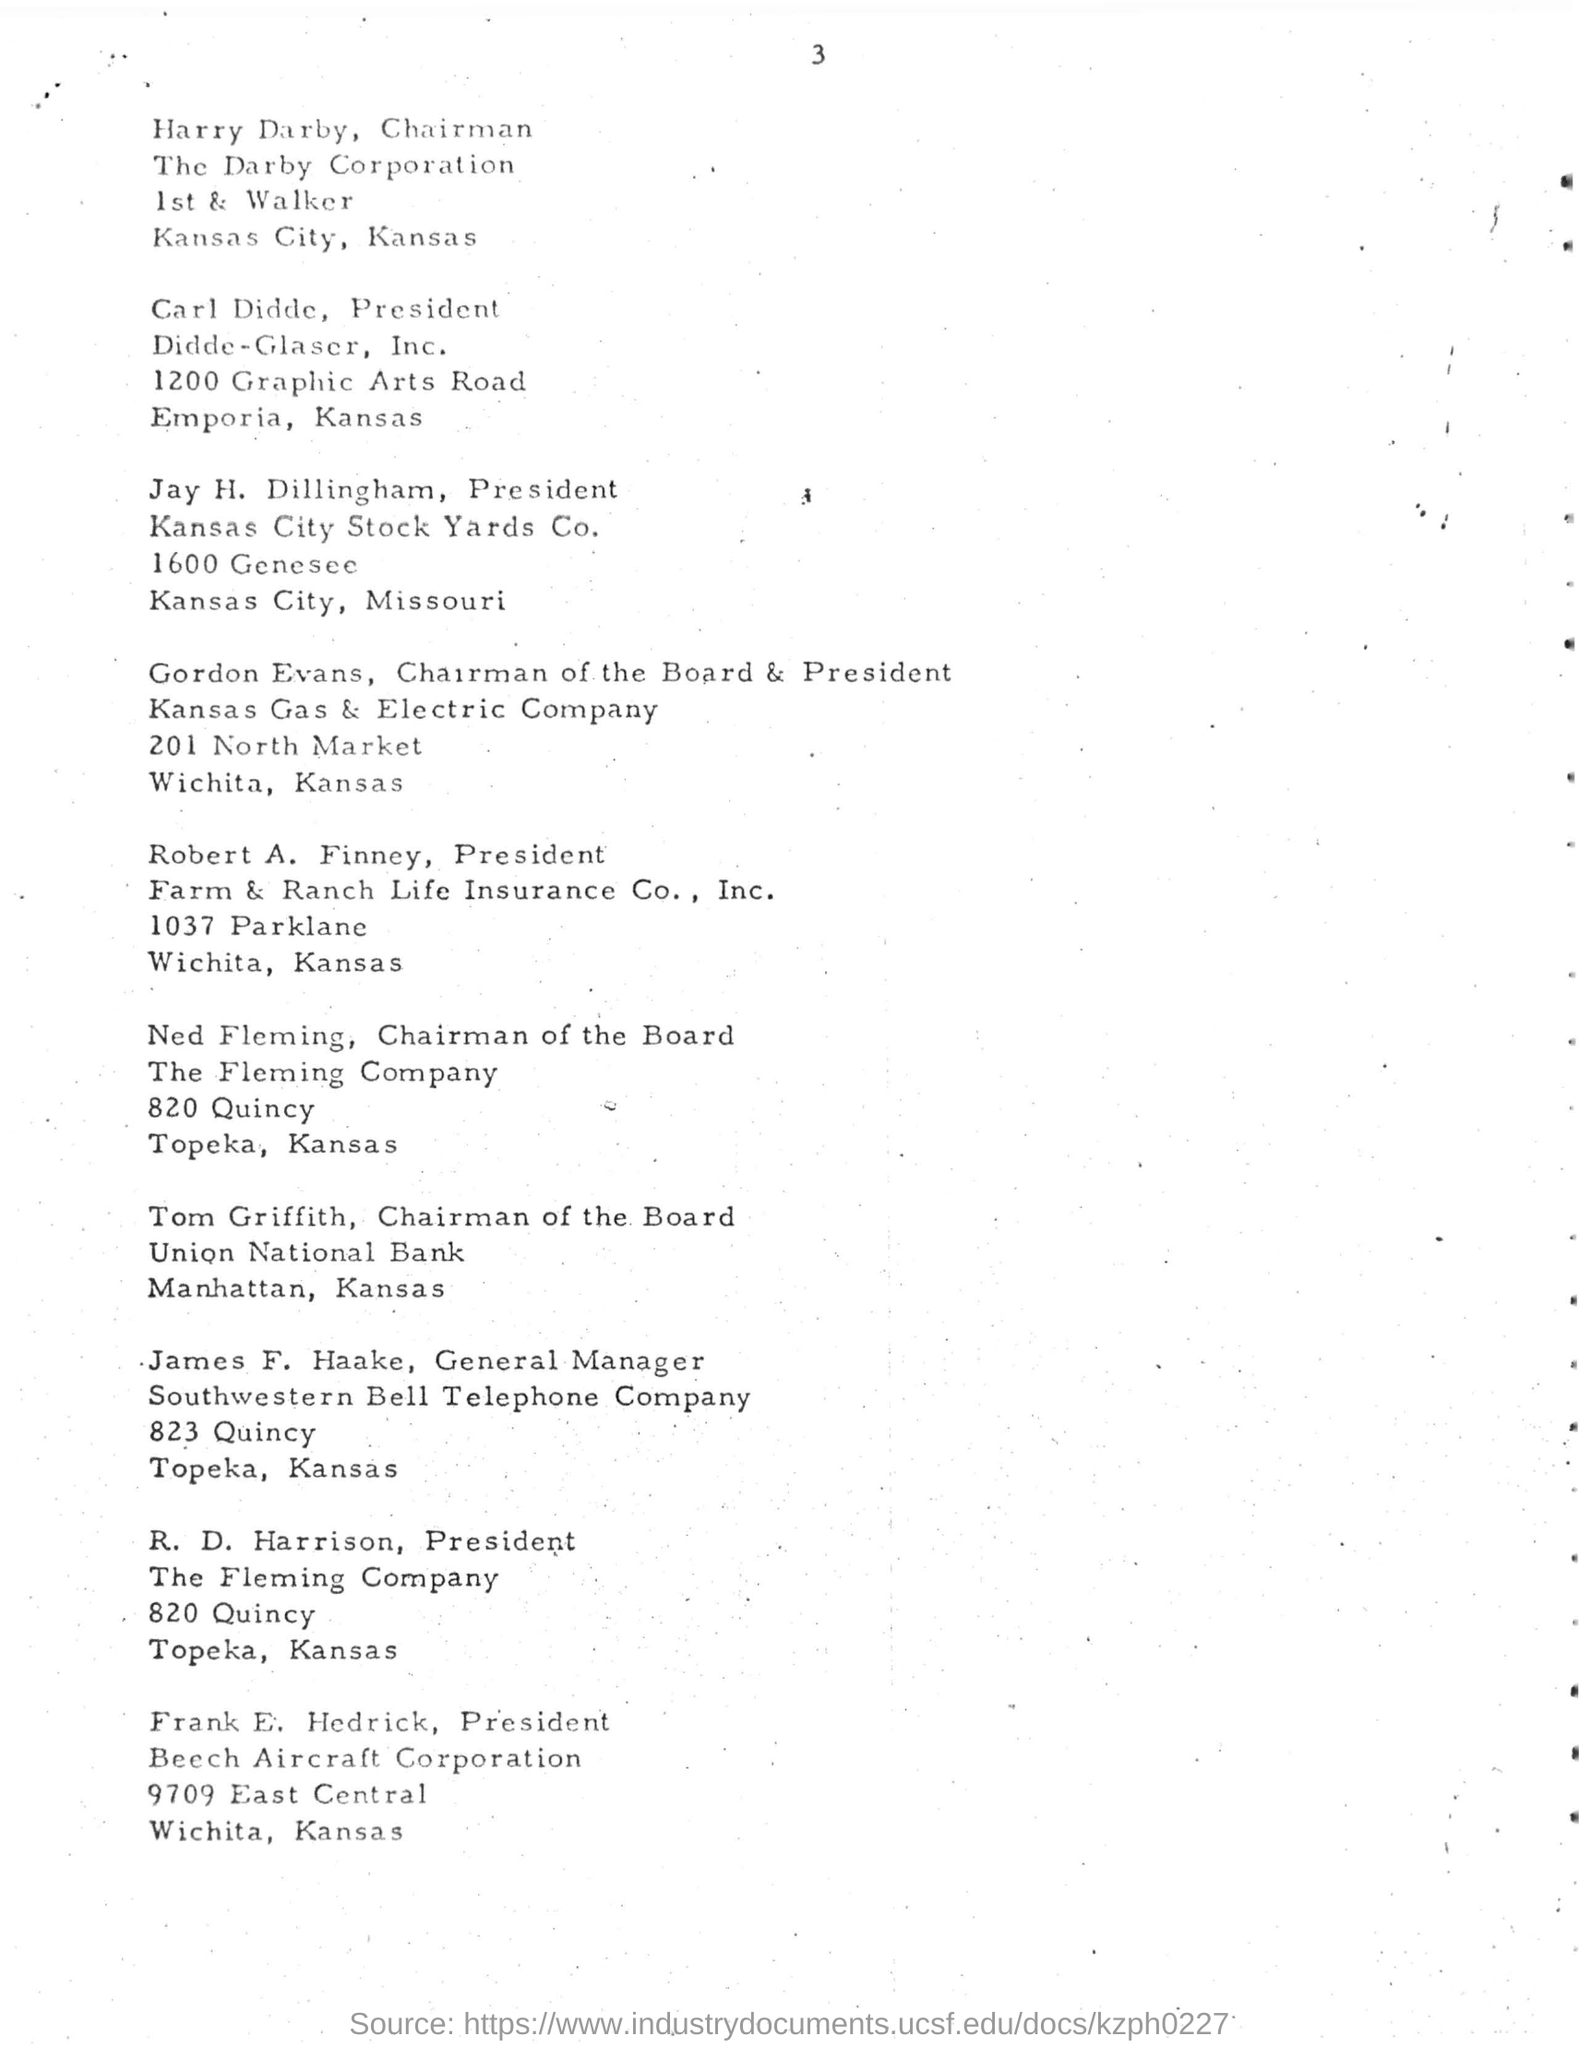Point out several critical features in this image. The Southwestern Bell Telephone Company is the name of the telephone company. R. D. Harrison has been designated as the president of the Fleming company. Frank E. Hedrick has been designated as the president of Beech Aircraft Corporation. Gordon Evans is the chairman of the board and the president of Kansas Gas & Electric Company. It is declared that Harry Darby is designated as the chairman for the Darby Corporation. 